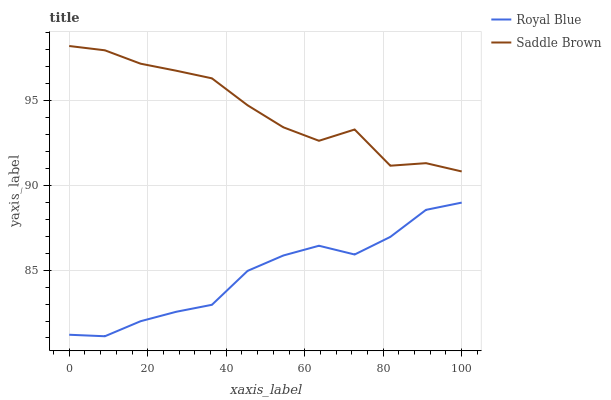Does Saddle Brown have the minimum area under the curve?
Answer yes or no. No. Is Saddle Brown the smoothest?
Answer yes or no. No. Does Saddle Brown have the lowest value?
Answer yes or no. No. Is Royal Blue less than Saddle Brown?
Answer yes or no. Yes. Is Saddle Brown greater than Royal Blue?
Answer yes or no. Yes. Does Royal Blue intersect Saddle Brown?
Answer yes or no. No. 